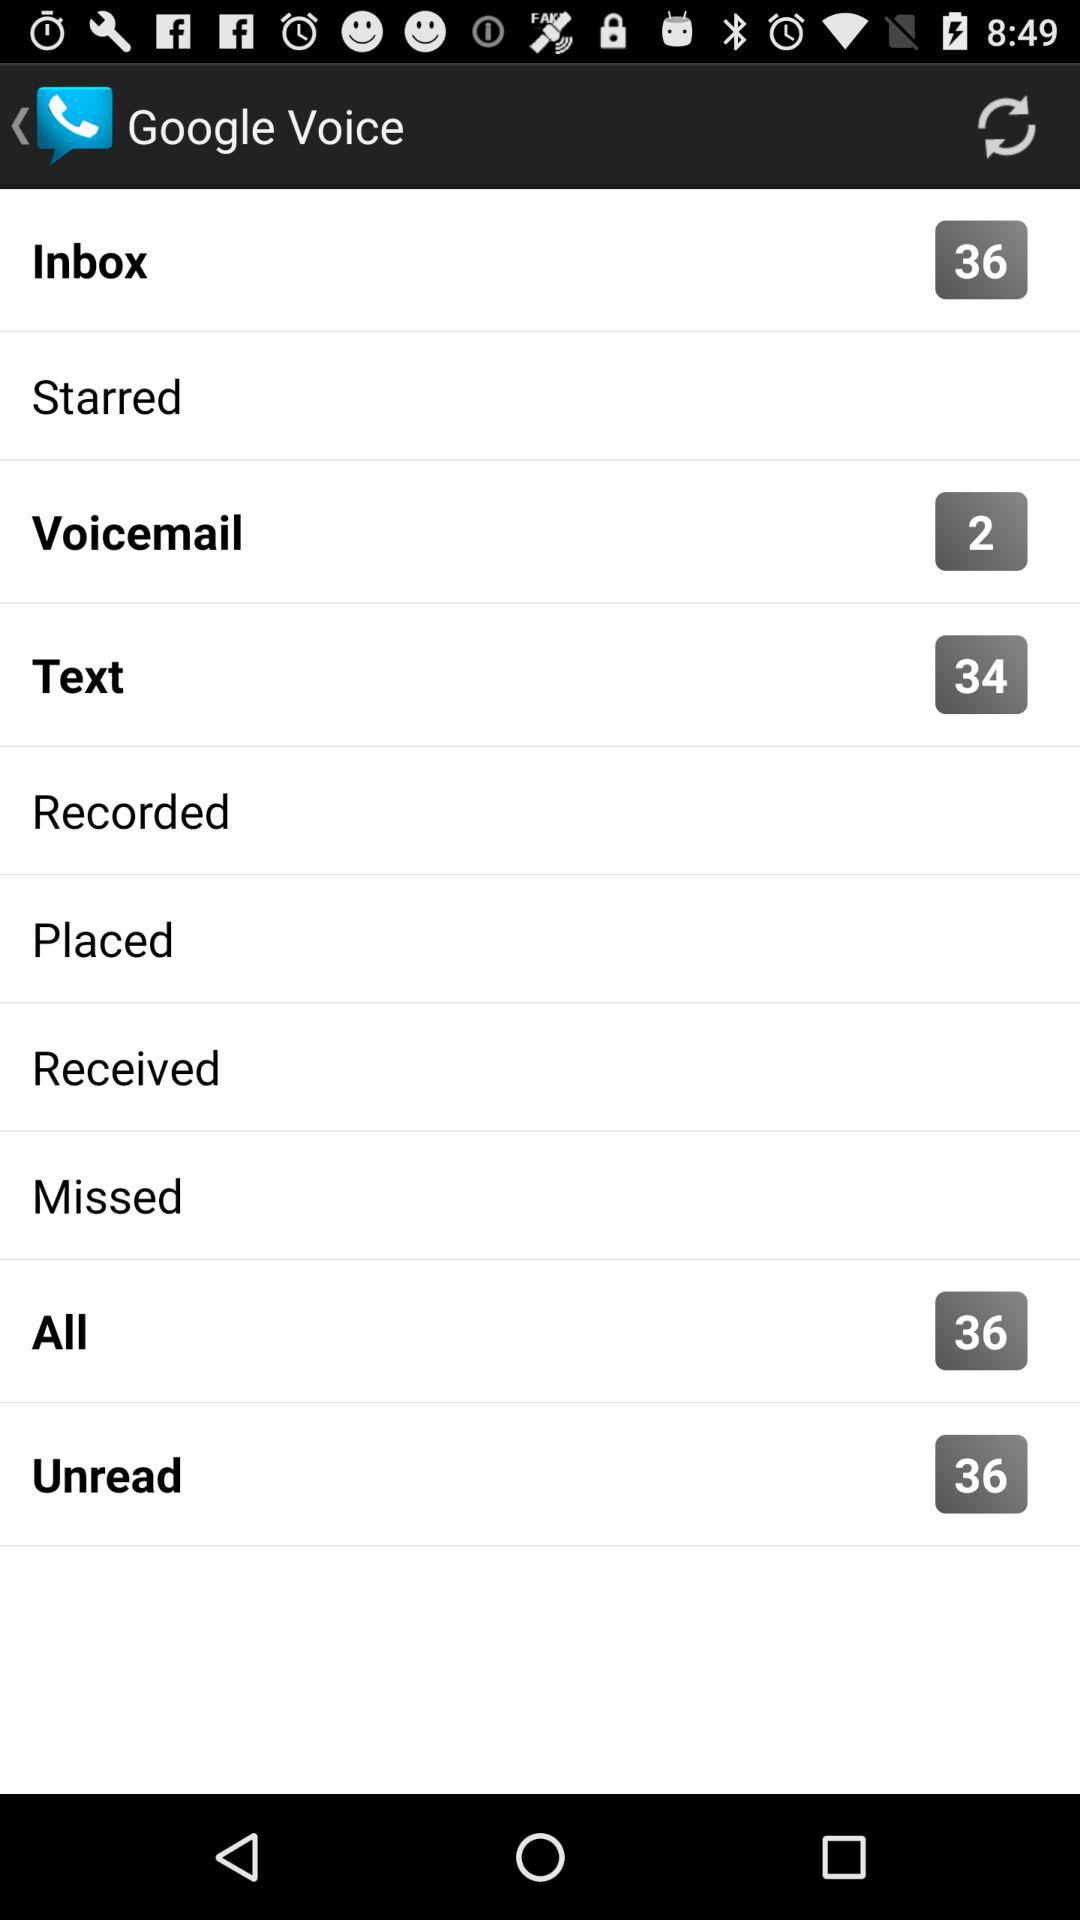How many texts are there? There are 34 texts. 